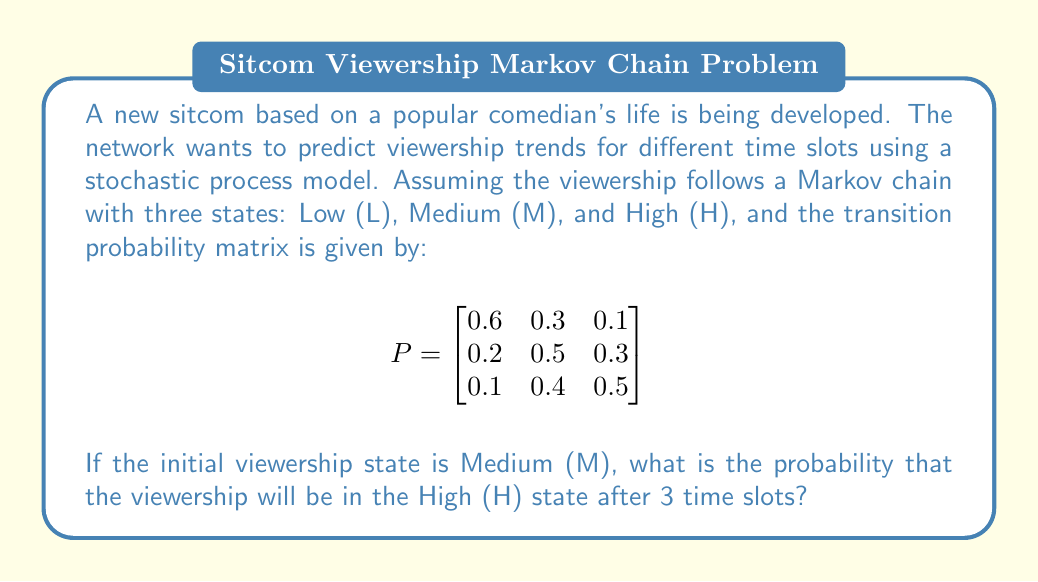Could you help me with this problem? To solve this problem, we need to use the properties of Markov chains and matrix multiplication. Let's follow these steps:

1) The initial state vector is $\pi_0 = [0 \quad 1 \quad 0]$, representing the Medium (M) state.

2) To find the state after 3 time slots, we need to multiply the initial state vector by the transition matrix raised to the power of 3:

   $\pi_3 = \pi_0 \cdot P^3$

3) Let's calculate $P^3$:

   $P^2 = P \cdot P = \begin{bmatrix}
   0.42 & 0.39 & 0.19 \\
   0.23 & 0.43 & 0.34 \\
   0.19 & 0.42 & 0.39
   \end{bmatrix}$

   $P^3 = P^2 \cdot P = \begin{bmatrix}
   0.353 & 0.399 & 0.248 \\
   0.263 & 0.412 & 0.325 \\
   0.233 & 0.411 & 0.356
   \end{bmatrix}$

4) Now, we multiply $\pi_0$ by $P^3$:

   $\pi_3 = [0 \quad 1 \quad 0] \cdot \begin{bmatrix}
   0.353 & 0.399 & 0.248 \\
   0.263 & 0.412 & 0.325 \\
   0.233 & 0.411 & 0.356
   \end{bmatrix}$

5) This multiplication selects the second row of $P^3$:

   $\pi_3 = [0.263 \quad 0.412 \quad 0.325]$

6) The probability of being in the High (H) state after 3 time slots is the third element of this vector: 0.325 or 32.5%.
Answer: 0.325 